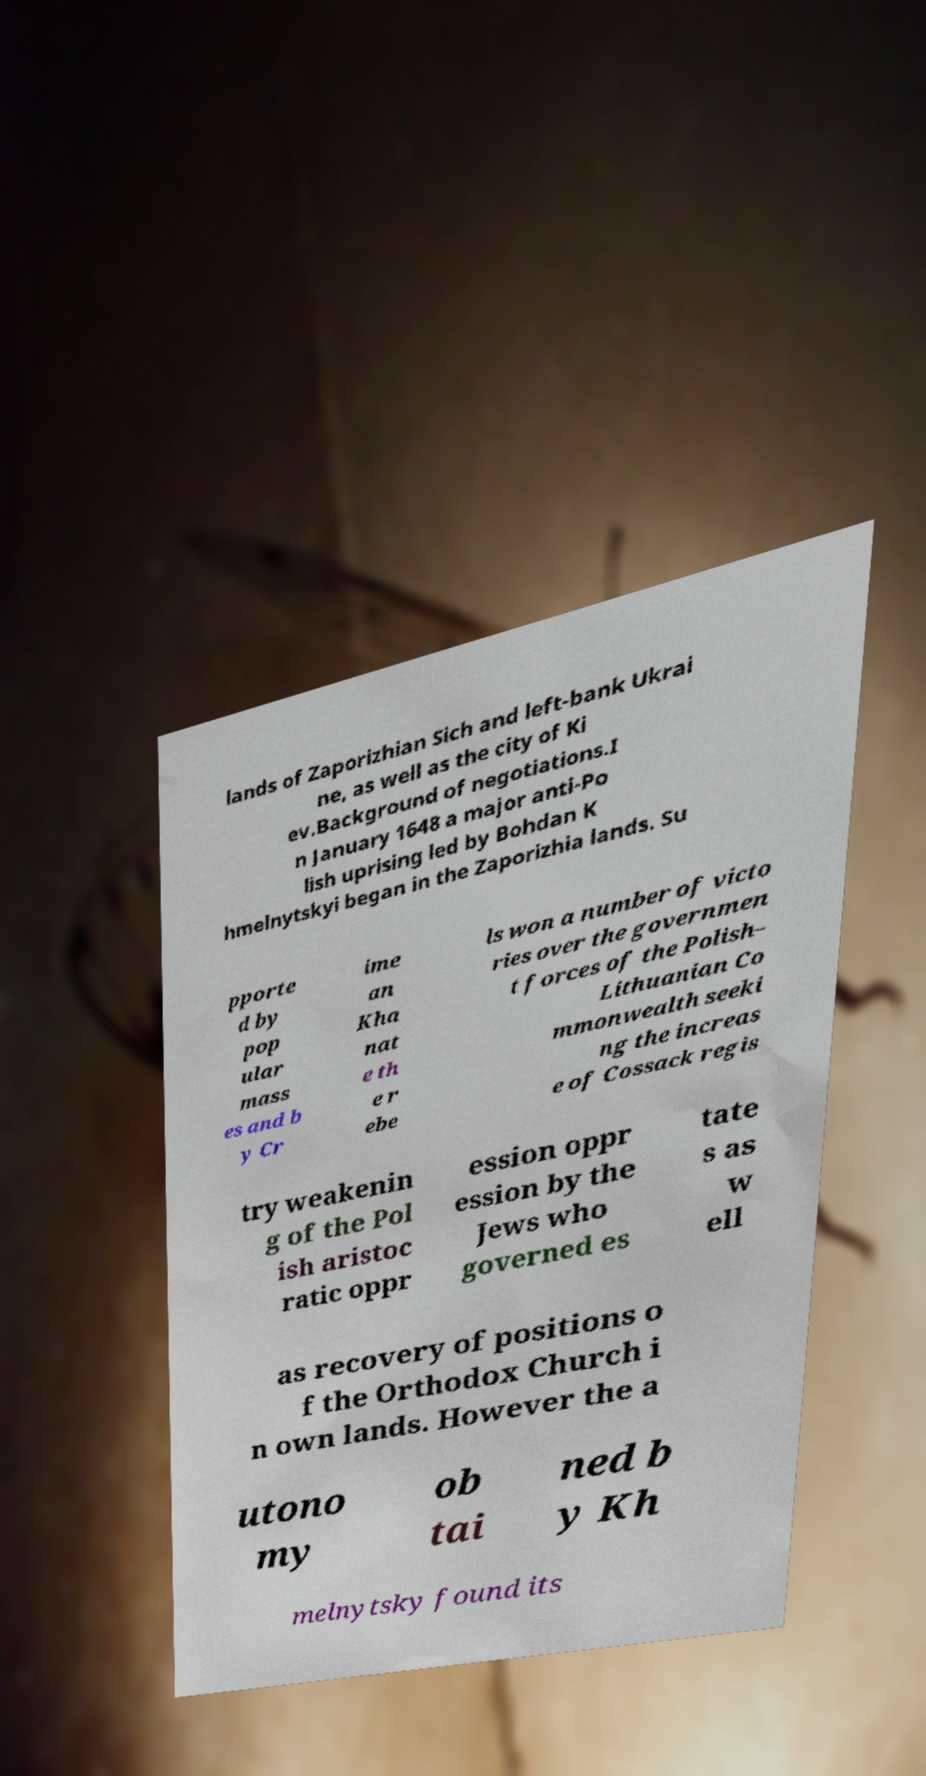Can you accurately transcribe the text from the provided image for me? lands of Zaporizhian Sich and left-bank Ukrai ne, as well as the city of Ki ev.Background of negotiations.I n January 1648 a major anti-Po lish uprising led by Bohdan K hmelnytskyi began in the Zaporizhia lands. Su pporte d by pop ular mass es and b y Cr ime an Kha nat e th e r ebe ls won a number of victo ries over the governmen t forces of the Polish– Lithuanian Co mmonwealth seeki ng the increas e of Cossack regis try weakenin g of the Pol ish aristoc ratic oppr ession oppr ession by the Jews who governed es tate s as w ell as recovery of positions o f the Orthodox Church i n own lands. However the a utono my ob tai ned b y Kh melnytsky found its 